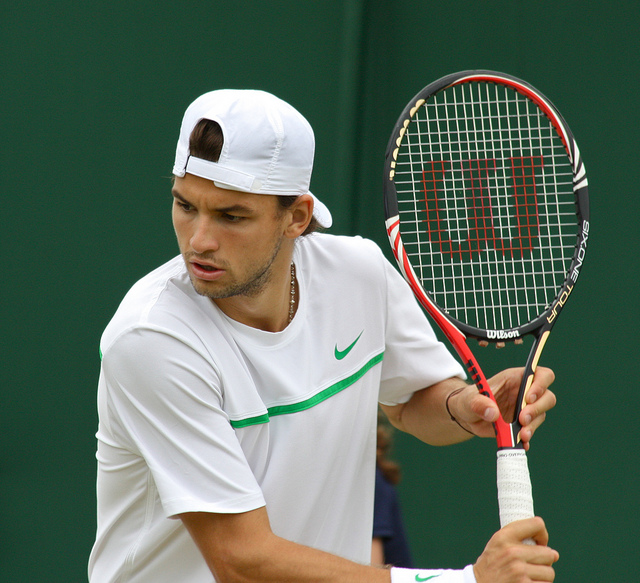Read all the text in this image. W SIXONET TOUR 